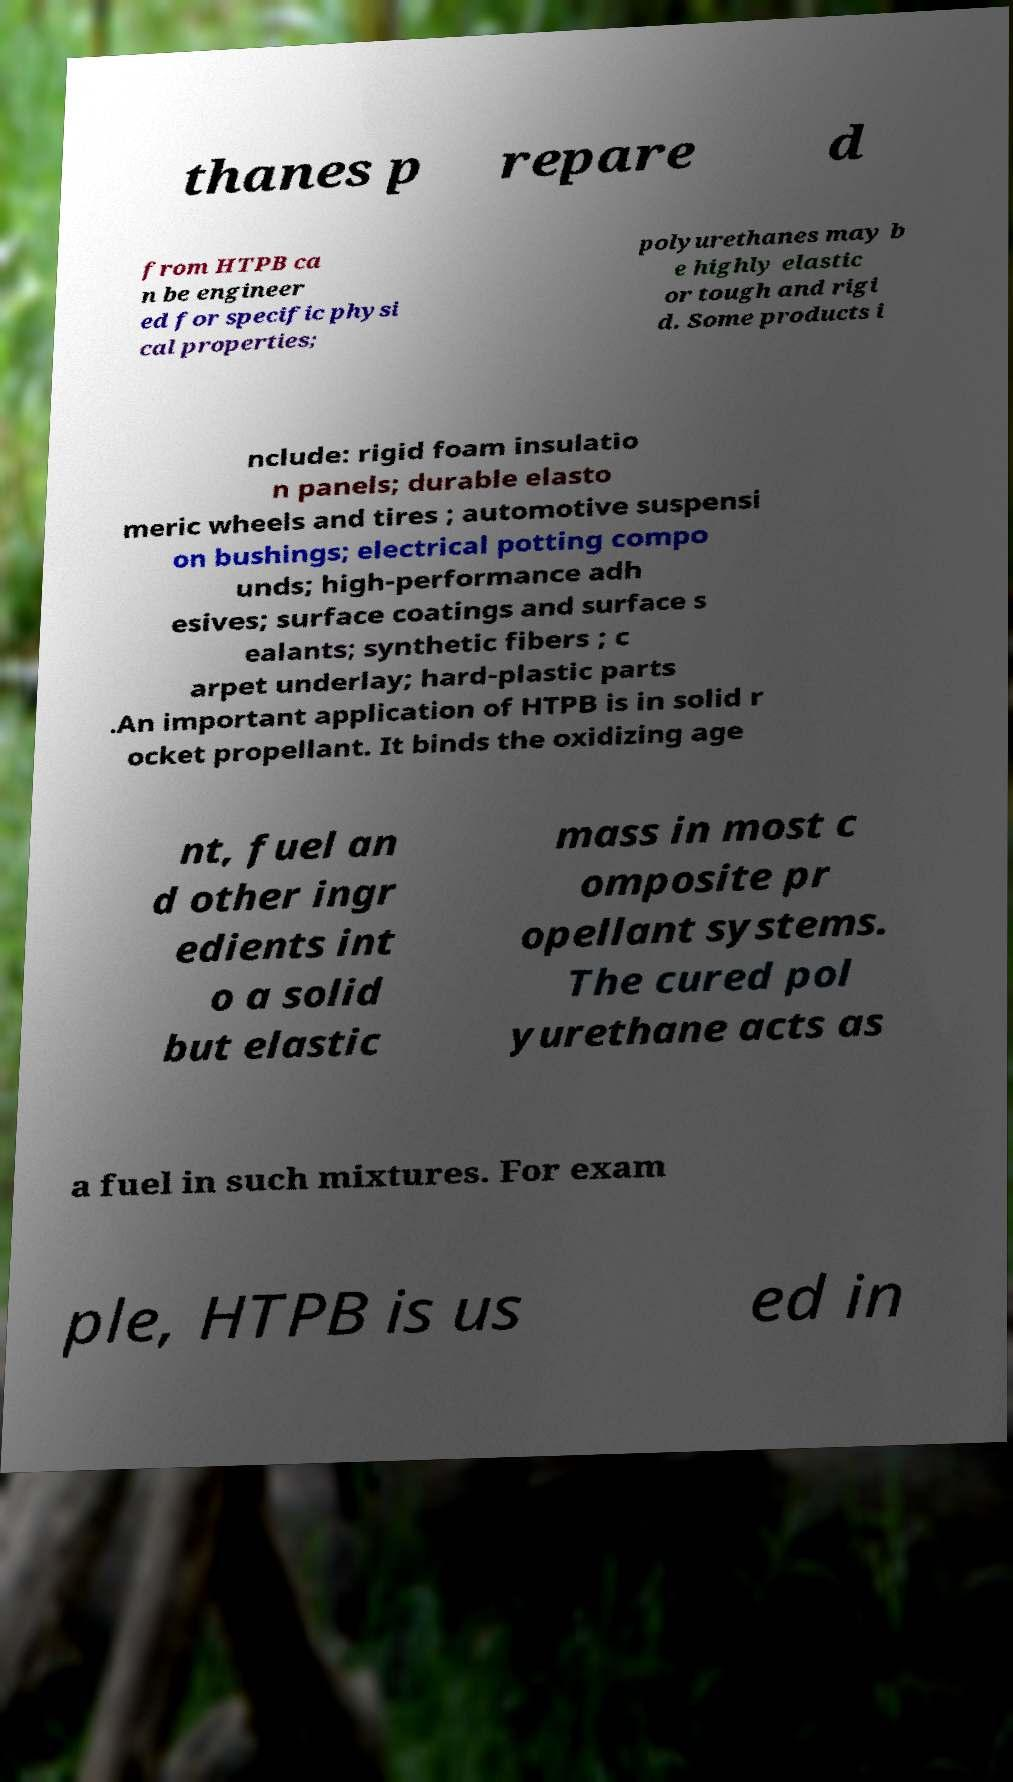I need the written content from this picture converted into text. Can you do that? thanes p repare d from HTPB ca n be engineer ed for specific physi cal properties; polyurethanes may b e highly elastic or tough and rigi d. Some products i nclude: rigid foam insulatio n panels; durable elasto meric wheels and tires ; automotive suspensi on bushings; electrical potting compo unds; high-performance adh esives; surface coatings and surface s ealants; synthetic fibers ; c arpet underlay; hard-plastic parts .An important application of HTPB is in solid r ocket propellant. It binds the oxidizing age nt, fuel an d other ingr edients int o a solid but elastic mass in most c omposite pr opellant systems. The cured pol yurethane acts as a fuel in such mixtures. For exam ple, HTPB is us ed in 